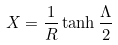Convert formula to latex. <formula><loc_0><loc_0><loc_500><loc_500>X = \frac { 1 } { R } \tanh \frac { \Lambda } { 2 }</formula> 